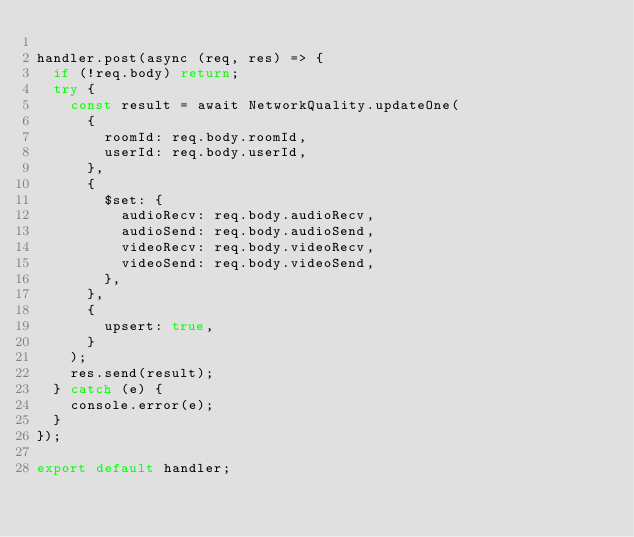Convert code to text. <code><loc_0><loc_0><loc_500><loc_500><_JavaScript_>
handler.post(async (req, res) => {
  if (!req.body) return;
  try {
    const result = await NetworkQuality.updateOne(
      {
        roomId: req.body.roomId,
        userId: req.body.userId,
      },
      {
        $set: {
          audioRecv: req.body.audioRecv,
          audioSend: req.body.audioSend,
          videoRecv: req.body.videoRecv,
          videoSend: req.body.videoSend,
        },
      },
      {
        upsert: true,
      }
    );
    res.send(result);
  } catch (e) {
    console.error(e);
  }
});

export default handler;
</code> 